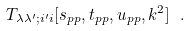Convert formula to latex. <formula><loc_0><loc_0><loc_500><loc_500>T _ { \lambda \lambda ^ { \prime } ; i ^ { \prime } i } [ s _ { p p } , t _ { p p } , u _ { p p } , k ^ { 2 } ] \ .</formula> 